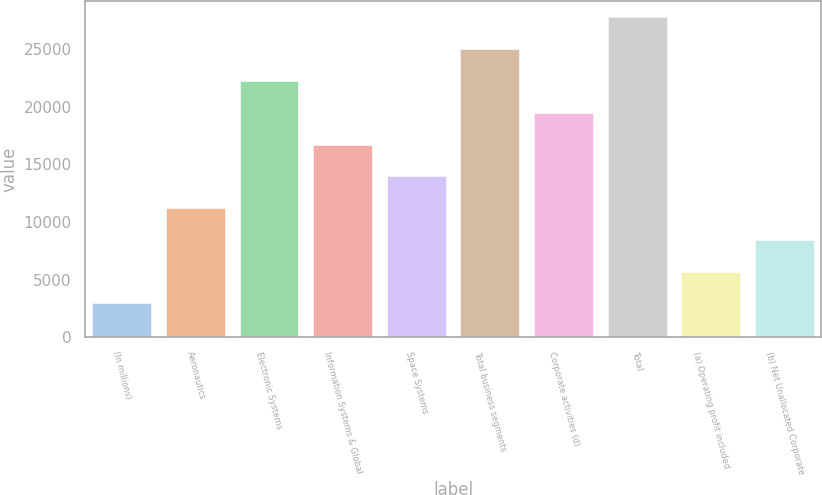<chart> <loc_0><loc_0><loc_500><loc_500><bar_chart><fcel>(In millions)<fcel>Aeronautics<fcel>Electronic Systems<fcel>Information Systems & Global<fcel>Space Systems<fcel>Total business segments<fcel>Corporate activities (d)<fcel>Total<fcel>(a) Operating profit included<fcel>(b) Net Unallocated Corporate<nl><fcel>2930.1<fcel>11201.4<fcel>22229.8<fcel>16715.6<fcel>13958.5<fcel>24986.9<fcel>19472.7<fcel>27744<fcel>5687.2<fcel>8444.3<nl></chart> 